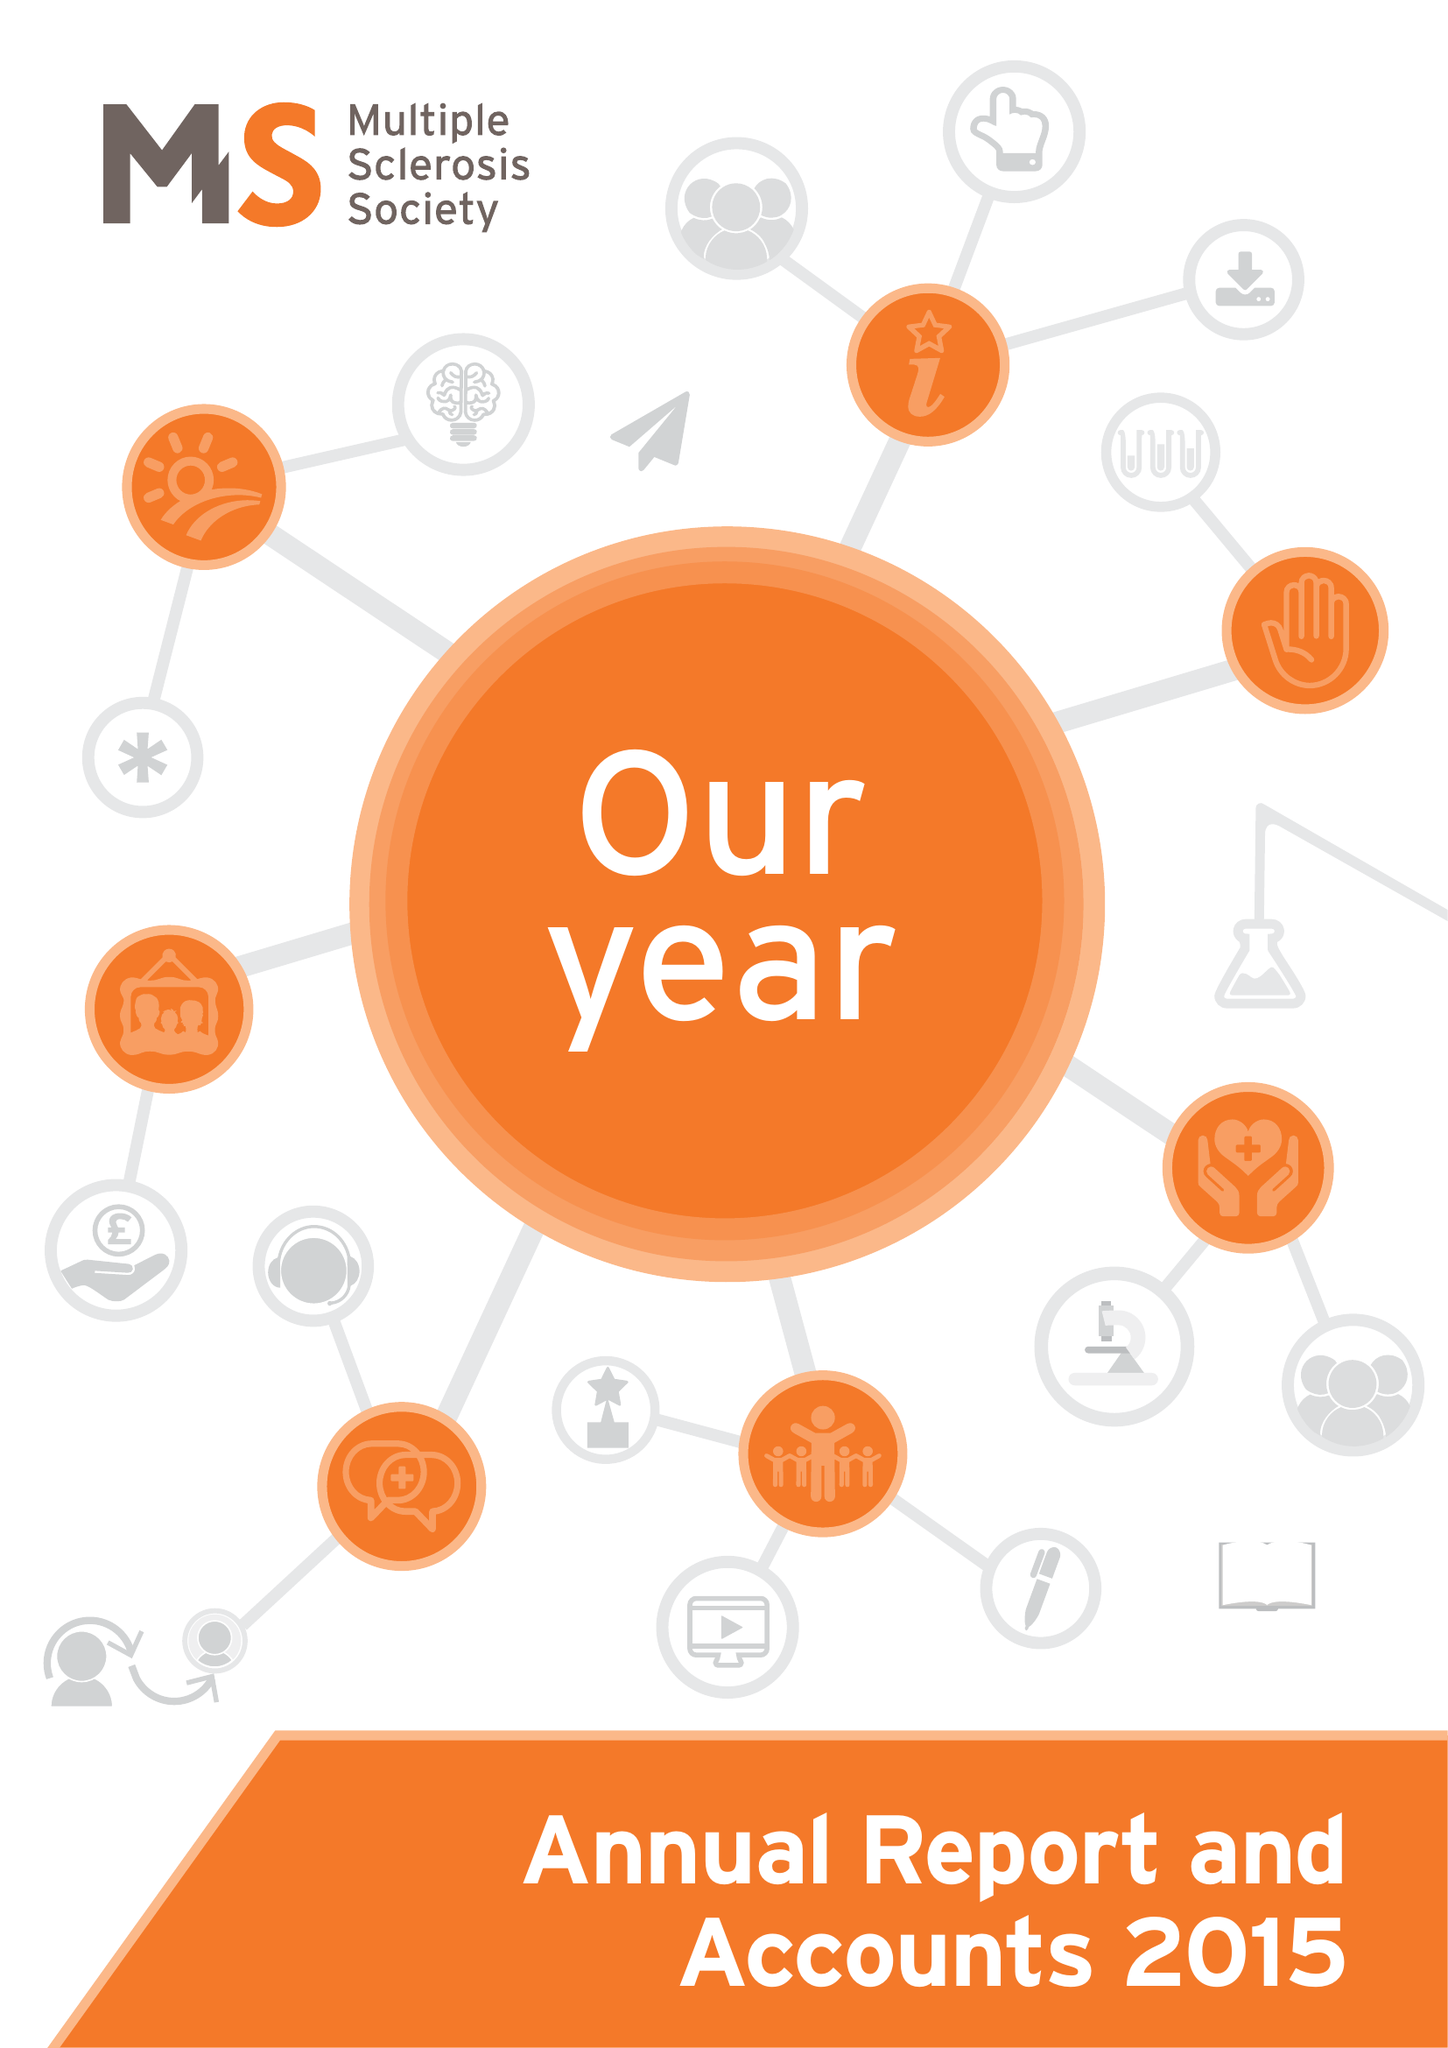What is the value for the address__post_town?
Answer the question using a single word or phrase. LONDON 